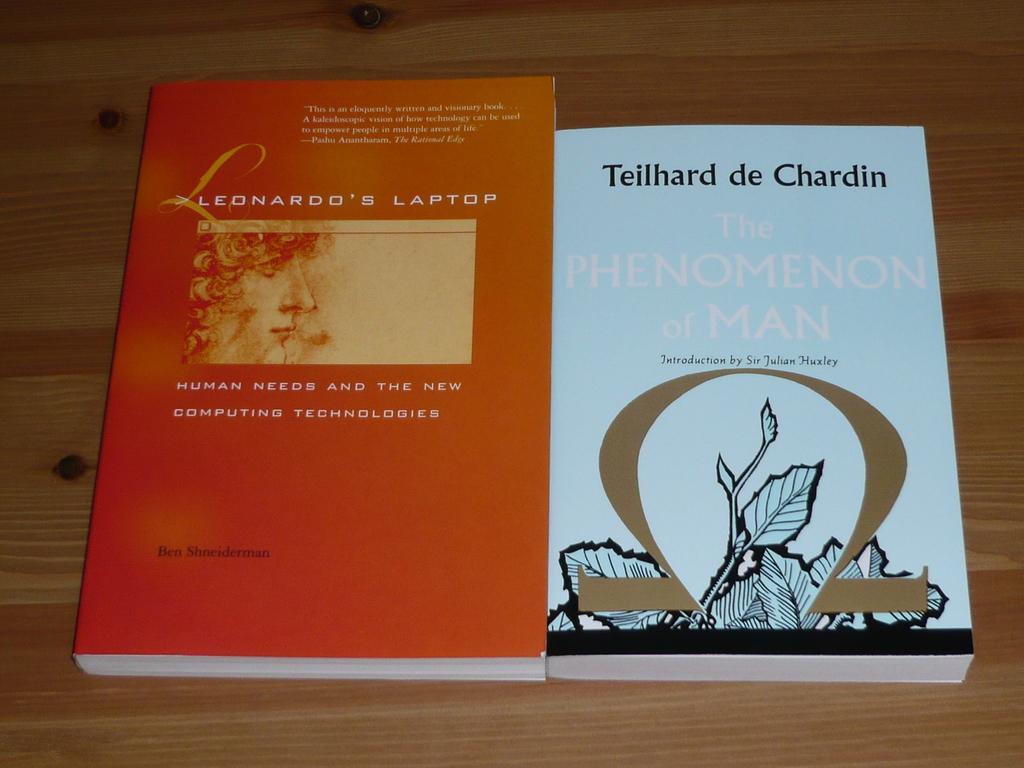Who is the writer of the book ?
Offer a terse response. Teilhard de chardin. What is the name of the book?
Ensure brevity in your answer.  The phenomenon of man. 